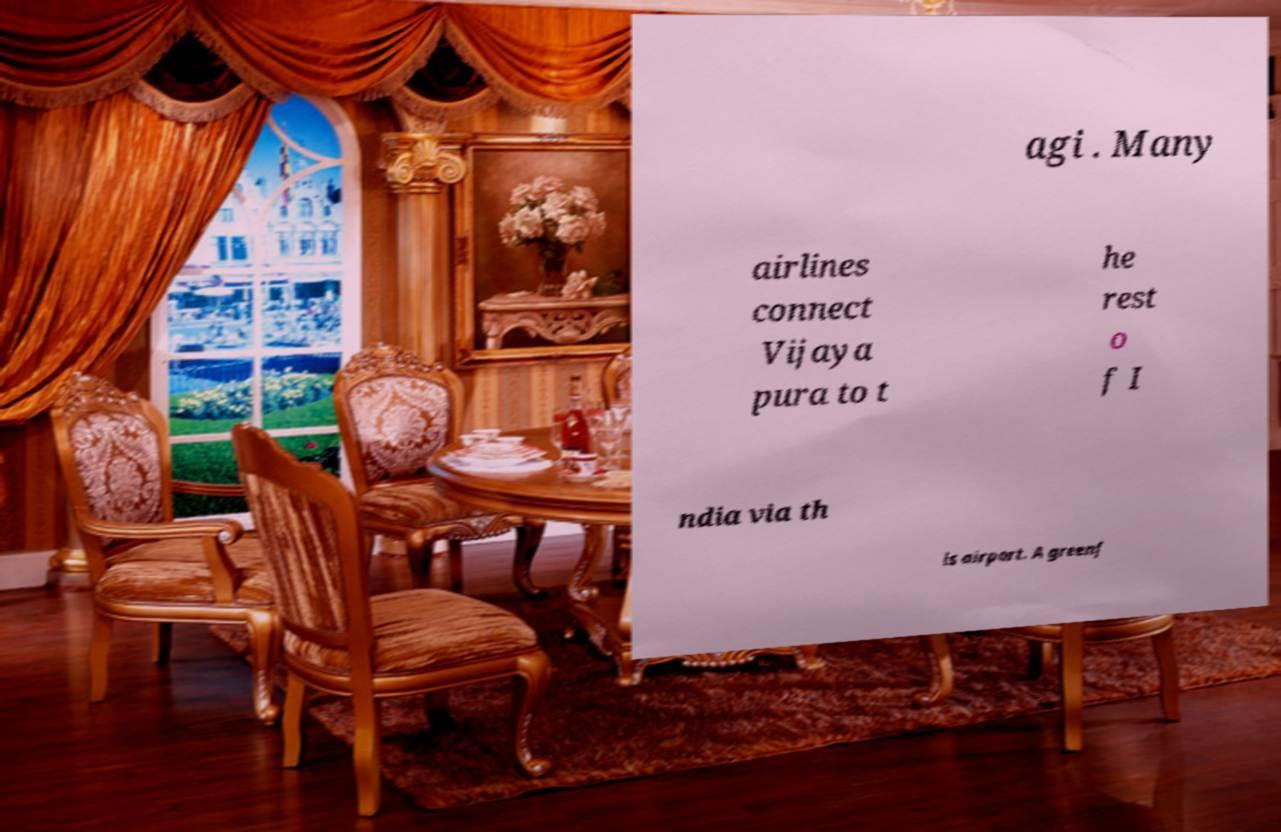Please identify and transcribe the text found in this image. agi . Many airlines connect Vijaya pura to t he rest o f I ndia via th is airport. A greenf 